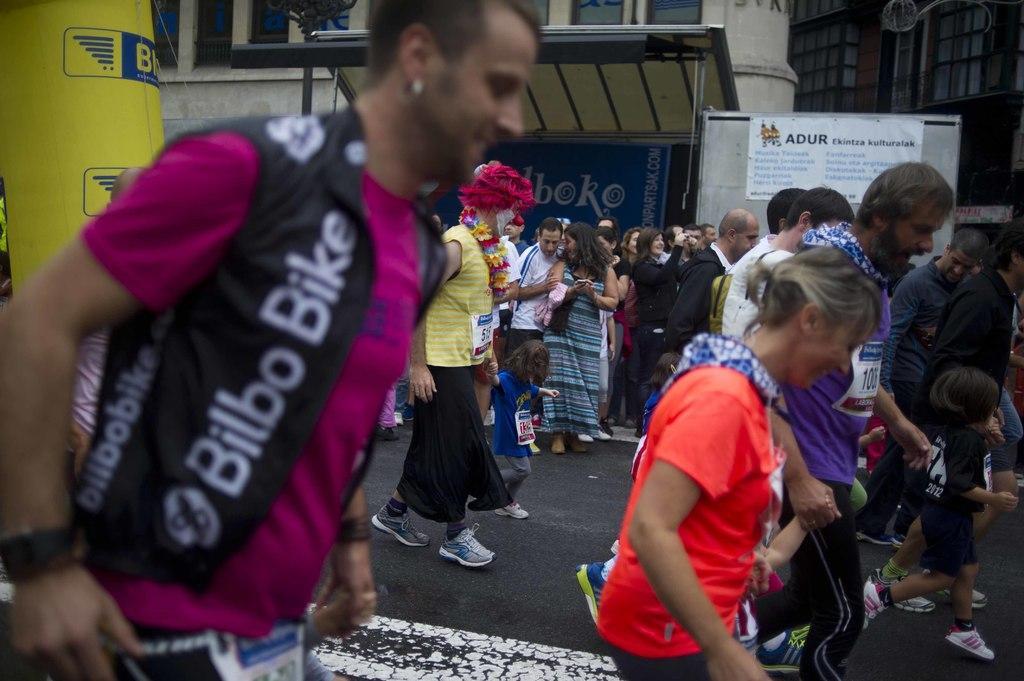Could you give a brief overview of what you see in this image? In this picture there are people on the road, banner on a board and hoarding. In the background of the image we can see buildings and board. In the top left side of the image we can see an object. 